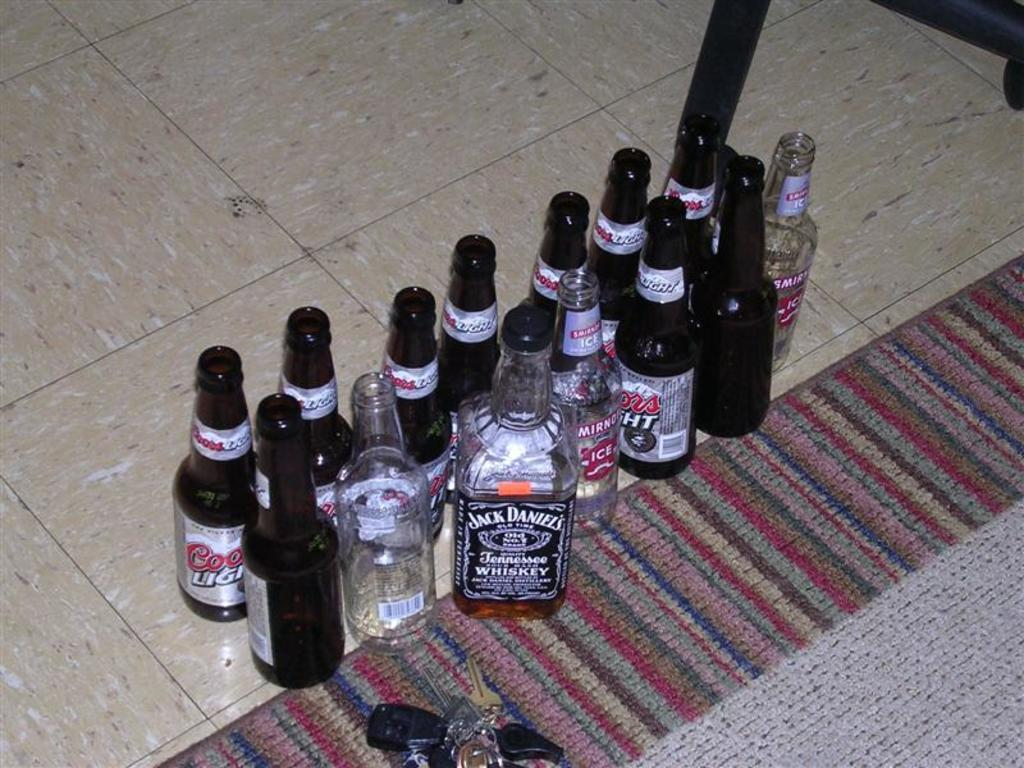What objects are on the floor in the image? There are bottles on the floor in the image. Can you describe the condition of the bottles? Some of the bottles are empty. What other item can be seen in the image? There is a bunch of keys in the image. What might be used as a floor covering in the image? There is a mat in the image. What type of news can be heard coming from the radio in the image? There is no radio present in the image, so it's not possible to determine what, if any, news might be heard. 